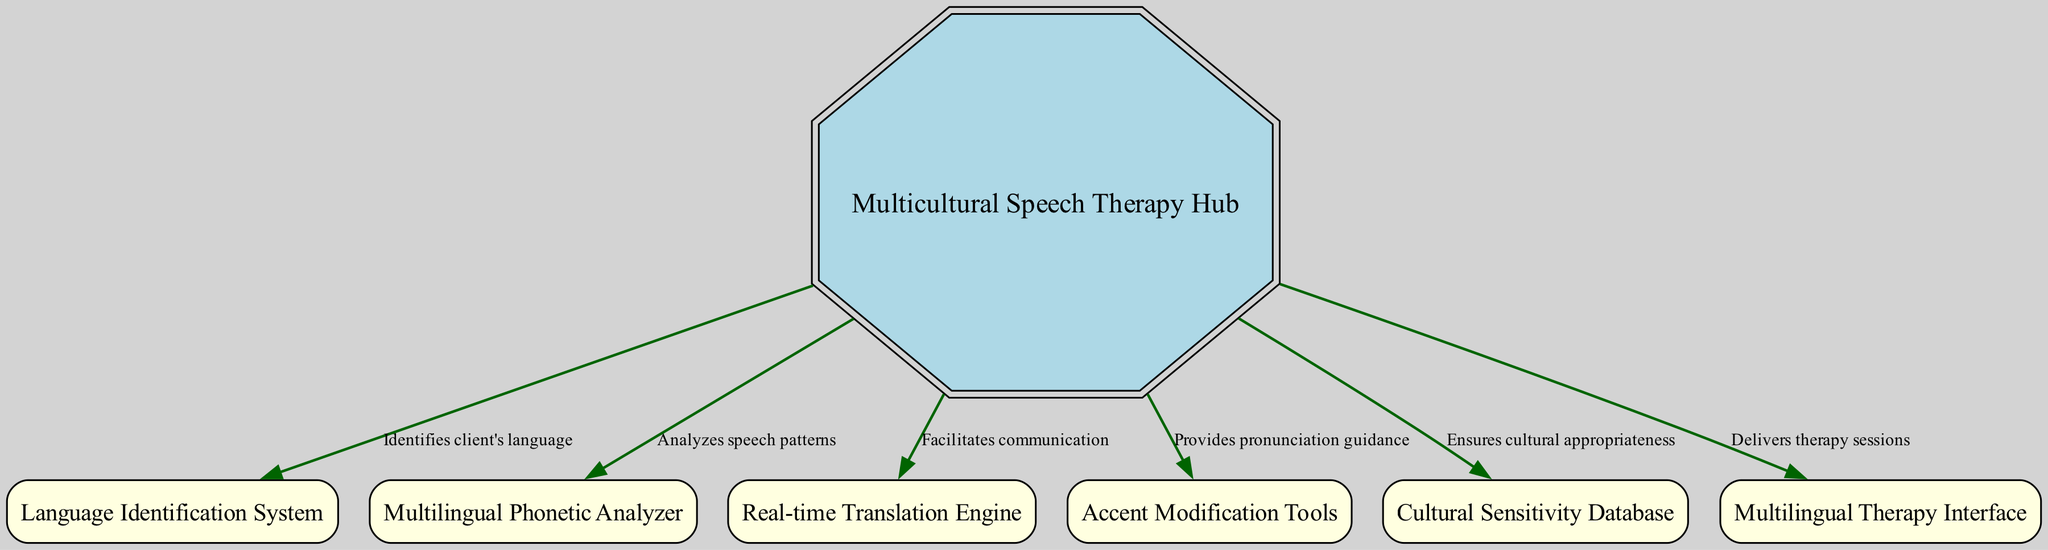What is the central hub's label in the diagram? The central hub is represented by a double octagon shape, and its label is "Multicultural Speech Therapy Hub," which is specified in the node details of the diagram.
Answer: Multicultural Speech Therapy Hub How many nodes are present in the diagram? By counting the nodes listed in the provided data, there are a total of 6 nodes, which include the central hub and five additional tools/systems.
Answer: 6 What does the Language Identification System do? The diagram indicates that the Language Identification System identifies the client's language, as stated in the edge label connecting it to the central hub.
Answer: Identifies client's language Which system is responsible for providing pronunciation guidance? The diagram shows that Accent Modification Tools provides pronunciation guidance, as indicated by the edge label from the central hub to this node.
Answer: Provides pronunciation guidance What is the relationship between the central hub and the Cultural Sensitivity Database? The edge connecting the central hub to the Cultural Sensitivity Database specifies that it ensures cultural appropriateness, reflecting the importance of cultural context in therapy.
Answer: Ensures cultural appropriateness What is the output of the system when a therapist needs to analyze speech patterns? The diagram indicates that the Phonetic Analyzer is the tool used to analyze speech patterns, which is directly connected to the central hub in the workflow.
Answer: Analyzes speech patterns What is the function of the Real-time Translation Engine? The Real-time Translation Engine facilitates communication according to the edge label connecting it to the central hub, indicating its role in bridging language gaps during therapy.
Answer: Facilitates communication How many edges connect the central hub to other systems? There are six edges connecting the central hub to various systems, including language identification, phonetic analysis, translation, accent modification, cultural database, and therapy interface, as detailed in the diagram.
Answer: 6 What does the Multilingual Therapy Interface provide? The diagram shows that the Multilingual Therapy Interface delivers therapy sessions, which is indicated through the connecting edge label to the central hub.
Answer: Delivers therapy sessions 